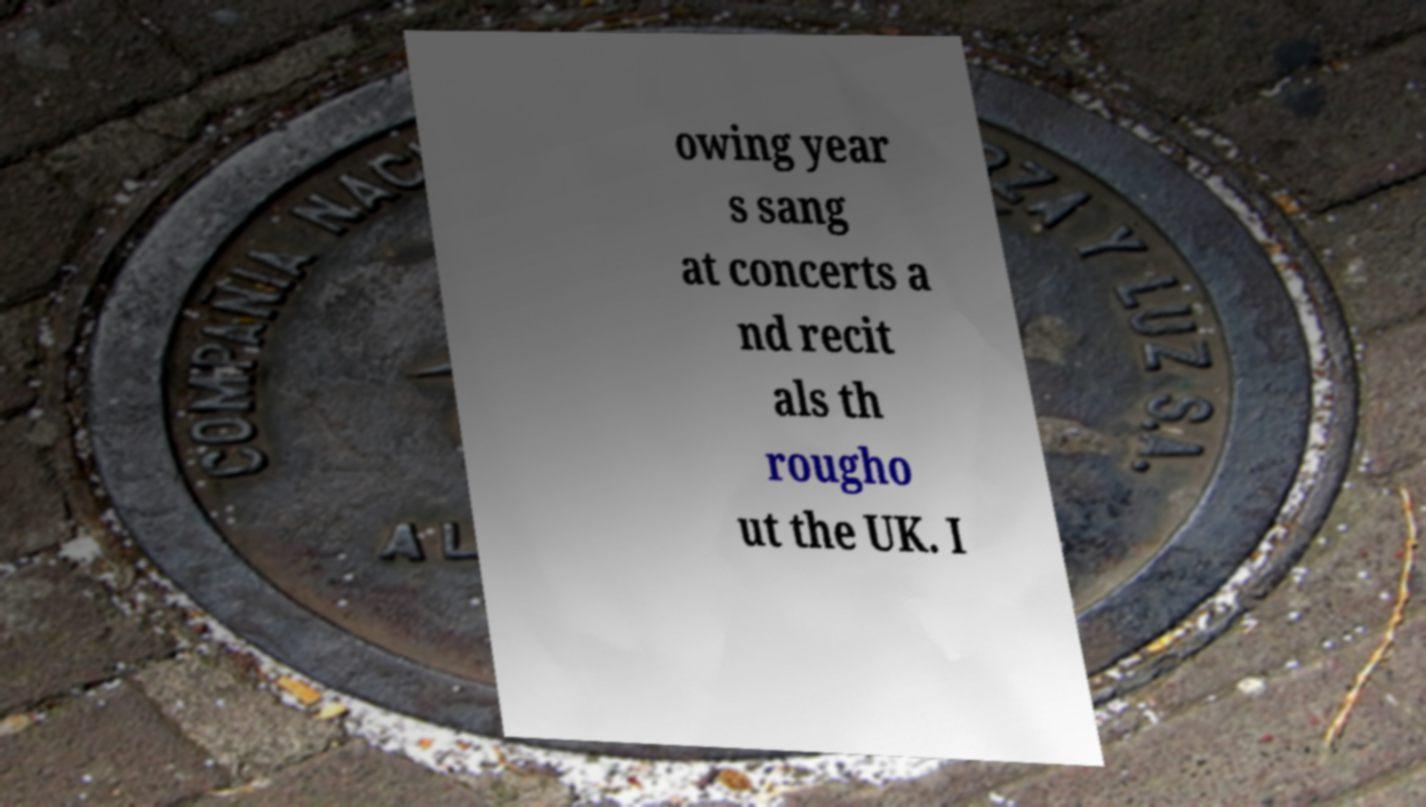Can you read and provide the text displayed in the image?This photo seems to have some interesting text. Can you extract and type it out for me? owing year s sang at concerts a nd recit als th rougho ut the UK. I 